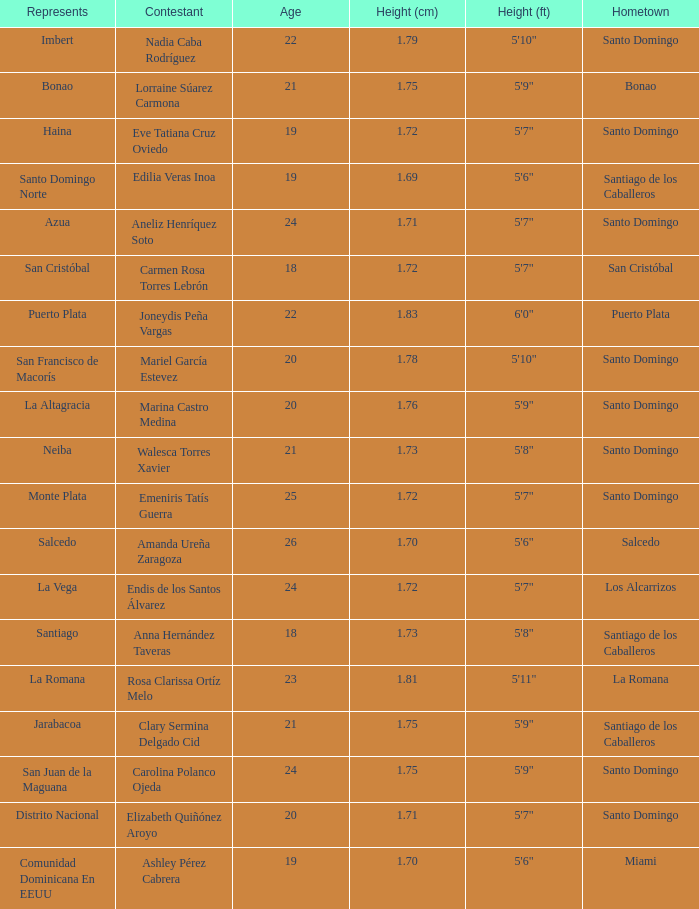Name the most age 26.0. 